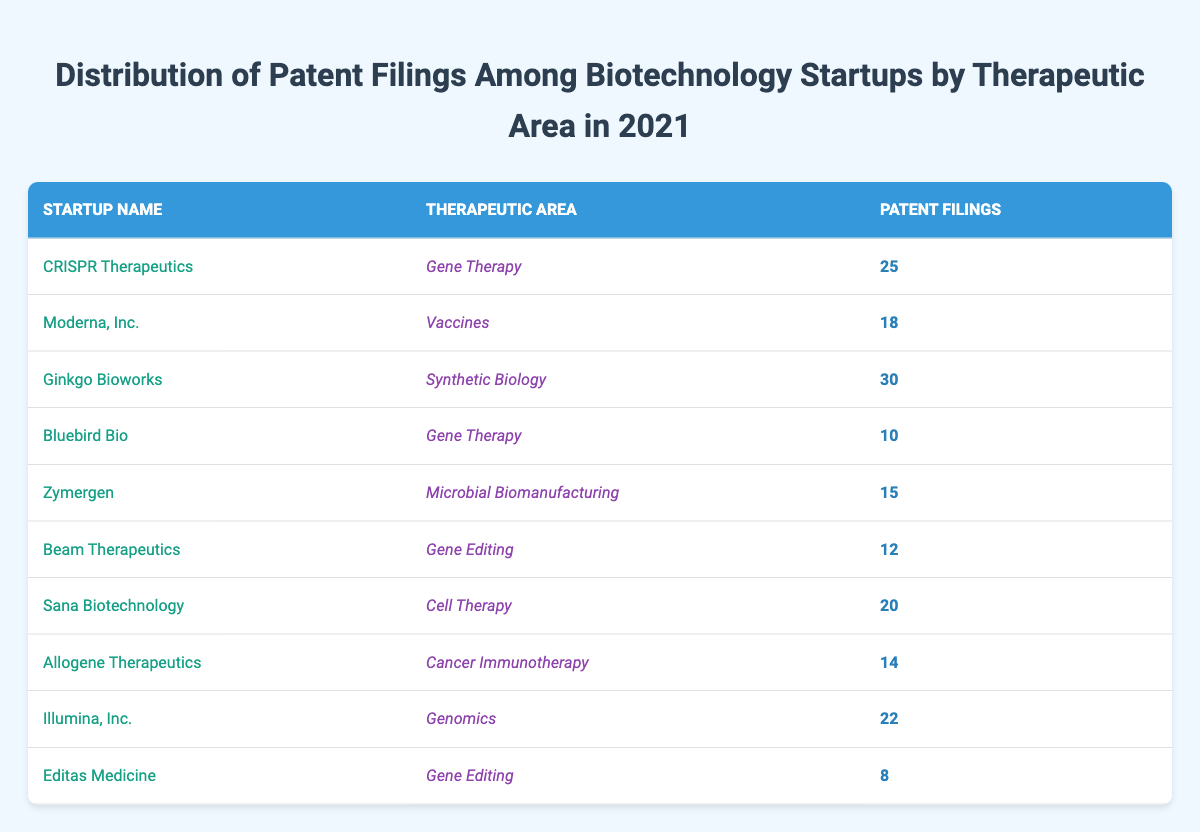What biotechnology startup has the highest number of patent filings in 2021? By reviewing the patent filings column, I see that Ginkgo Bioworks has the highest count with 30 patent filings.
Answer: Ginkgo Bioworks How many patent filings does Sana Biotechnology have? Looking at the table, Sana Biotechnology has 20 patent filings listed under the patent filings column.
Answer: 20 Which therapeutic area has the fewest total patent filings from the listed startups? First, I will sum the patent filings for each therapeutic area: Gene Therapy (25 + 10 = 35), Vaccines (18), Synthetic Biology (30), Microbial Biomanufacturing (15), Gene Editing (12 + 8 = 20), Cell Therapy (20), Cancer Immunotherapy (14), Genomics (22). The therapeutic area with the fewest filings is Gene Editing with a total of 20 patent filings.
Answer: Gene Editing Is it true that Beam Therapeutics has more patent filings than Allogene Therapeutics? I will compare the patent filings: Beam Therapeutics has 12 filings and Allogene Therapeutics has 14 filings. Since 12 is less than 14, the statement is false.
Answer: No What is the average number of patent filings among the listed biotechnology startups? First, I will sum the total patent filings (25 + 18 + 30 + 10 + 15 + 12 + 20 + 14 + 22 + 8 =  180). There are 10 startups in total, so I will divide the sum by the number of startups: 180 / 10 = 18.
Answer: 18 How many startups are involved in Gene Therapy? The table shows that there are two startups in the Gene Therapy area: CRISPR Therapeutics and Bluebird Bio.
Answer: 2 What is the difference in patent filings between the startup with the most filings and the startup with the least filings? Ginkgo Bioworks has the most with 30 filings, and Editas Medicine has the least with 8 filings. The difference is calculated as 30 - 8 = 22.
Answer: 22 Which startup in the Vaccines therapeutic area has patent filings? The table shows only one startup under Vaccines, which is Moderna, Inc. with 18 patent filings.
Answer: Moderna, Inc 